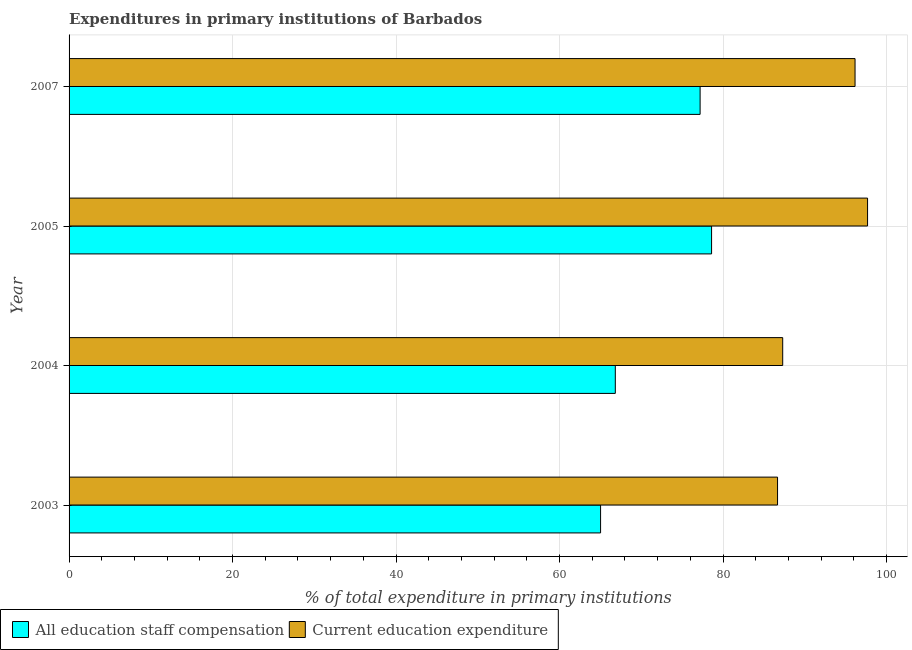How many groups of bars are there?
Keep it short and to the point. 4. Are the number of bars on each tick of the Y-axis equal?
Your answer should be very brief. Yes. How many bars are there on the 1st tick from the bottom?
Give a very brief answer. 2. What is the label of the 4th group of bars from the top?
Offer a very short reply. 2003. What is the expenditure in staff compensation in 2004?
Provide a short and direct response. 66.82. Across all years, what is the maximum expenditure in staff compensation?
Your answer should be very brief. 78.59. Across all years, what is the minimum expenditure in education?
Ensure brevity in your answer.  86.66. In which year was the expenditure in staff compensation maximum?
Make the answer very short. 2005. In which year was the expenditure in education minimum?
Your answer should be compact. 2003. What is the total expenditure in education in the graph?
Make the answer very short. 367.78. What is the difference between the expenditure in staff compensation in 2005 and that in 2007?
Provide a short and direct response. 1.4. What is the difference between the expenditure in education in 2005 and the expenditure in staff compensation in 2007?
Your response must be concise. 20.48. What is the average expenditure in staff compensation per year?
Give a very brief answer. 71.91. In the year 2004, what is the difference between the expenditure in staff compensation and expenditure in education?
Your answer should be very brief. -20.48. In how many years, is the expenditure in education greater than 72 %?
Ensure brevity in your answer.  4. What is the ratio of the expenditure in staff compensation in 2005 to that in 2007?
Make the answer very short. 1.02. Is the expenditure in education in 2003 less than that in 2004?
Provide a succinct answer. Yes. What is the difference between the highest and the second highest expenditure in staff compensation?
Provide a short and direct response. 1.4. What is the difference between the highest and the lowest expenditure in education?
Keep it short and to the point. 11.01. What does the 2nd bar from the top in 2004 represents?
Your answer should be compact. All education staff compensation. What does the 2nd bar from the bottom in 2007 represents?
Offer a very short reply. Current education expenditure. Are all the bars in the graph horizontal?
Your response must be concise. Yes. What is the difference between two consecutive major ticks on the X-axis?
Provide a short and direct response. 20. Does the graph contain any zero values?
Keep it short and to the point. No. Does the graph contain grids?
Give a very brief answer. Yes. Where does the legend appear in the graph?
Make the answer very short. Bottom left. How many legend labels are there?
Give a very brief answer. 2. How are the legend labels stacked?
Your response must be concise. Horizontal. What is the title of the graph?
Your response must be concise. Expenditures in primary institutions of Barbados. Does "Primary education" appear as one of the legend labels in the graph?
Ensure brevity in your answer.  No. What is the label or title of the X-axis?
Offer a very short reply. % of total expenditure in primary institutions. What is the label or title of the Y-axis?
Provide a short and direct response. Year. What is the % of total expenditure in primary institutions in All education staff compensation in 2003?
Give a very brief answer. 65.02. What is the % of total expenditure in primary institutions of Current education expenditure in 2003?
Offer a terse response. 86.66. What is the % of total expenditure in primary institutions in All education staff compensation in 2004?
Offer a very short reply. 66.82. What is the % of total expenditure in primary institutions in Current education expenditure in 2004?
Your response must be concise. 87.29. What is the % of total expenditure in primary institutions of All education staff compensation in 2005?
Offer a very short reply. 78.59. What is the % of total expenditure in primary institutions of Current education expenditure in 2005?
Your answer should be very brief. 97.68. What is the % of total expenditure in primary institutions of All education staff compensation in 2007?
Offer a terse response. 77.19. What is the % of total expenditure in primary institutions of Current education expenditure in 2007?
Offer a very short reply. 96.14. Across all years, what is the maximum % of total expenditure in primary institutions in All education staff compensation?
Keep it short and to the point. 78.59. Across all years, what is the maximum % of total expenditure in primary institutions of Current education expenditure?
Your response must be concise. 97.68. Across all years, what is the minimum % of total expenditure in primary institutions of All education staff compensation?
Your answer should be compact. 65.02. Across all years, what is the minimum % of total expenditure in primary institutions in Current education expenditure?
Offer a terse response. 86.66. What is the total % of total expenditure in primary institutions of All education staff compensation in the graph?
Ensure brevity in your answer.  287.62. What is the total % of total expenditure in primary institutions in Current education expenditure in the graph?
Ensure brevity in your answer.  367.78. What is the difference between the % of total expenditure in primary institutions of All education staff compensation in 2003 and that in 2004?
Keep it short and to the point. -1.8. What is the difference between the % of total expenditure in primary institutions in Current education expenditure in 2003 and that in 2004?
Offer a terse response. -0.63. What is the difference between the % of total expenditure in primary institutions in All education staff compensation in 2003 and that in 2005?
Your answer should be very brief. -13.58. What is the difference between the % of total expenditure in primary institutions of Current education expenditure in 2003 and that in 2005?
Keep it short and to the point. -11.01. What is the difference between the % of total expenditure in primary institutions in All education staff compensation in 2003 and that in 2007?
Give a very brief answer. -12.17. What is the difference between the % of total expenditure in primary institutions in Current education expenditure in 2003 and that in 2007?
Make the answer very short. -9.48. What is the difference between the % of total expenditure in primary institutions in All education staff compensation in 2004 and that in 2005?
Your answer should be compact. -11.77. What is the difference between the % of total expenditure in primary institutions of Current education expenditure in 2004 and that in 2005?
Your answer should be compact. -10.38. What is the difference between the % of total expenditure in primary institutions in All education staff compensation in 2004 and that in 2007?
Provide a succinct answer. -10.37. What is the difference between the % of total expenditure in primary institutions of Current education expenditure in 2004 and that in 2007?
Ensure brevity in your answer.  -8.85. What is the difference between the % of total expenditure in primary institutions in All education staff compensation in 2005 and that in 2007?
Provide a succinct answer. 1.4. What is the difference between the % of total expenditure in primary institutions in Current education expenditure in 2005 and that in 2007?
Ensure brevity in your answer.  1.53. What is the difference between the % of total expenditure in primary institutions in All education staff compensation in 2003 and the % of total expenditure in primary institutions in Current education expenditure in 2004?
Offer a terse response. -22.28. What is the difference between the % of total expenditure in primary institutions in All education staff compensation in 2003 and the % of total expenditure in primary institutions in Current education expenditure in 2005?
Offer a very short reply. -32.66. What is the difference between the % of total expenditure in primary institutions in All education staff compensation in 2003 and the % of total expenditure in primary institutions in Current education expenditure in 2007?
Give a very brief answer. -31.13. What is the difference between the % of total expenditure in primary institutions in All education staff compensation in 2004 and the % of total expenditure in primary institutions in Current education expenditure in 2005?
Give a very brief answer. -30.86. What is the difference between the % of total expenditure in primary institutions in All education staff compensation in 2004 and the % of total expenditure in primary institutions in Current education expenditure in 2007?
Offer a terse response. -29.32. What is the difference between the % of total expenditure in primary institutions of All education staff compensation in 2005 and the % of total expenditure in primary institutions of Current education expenditure in 2007?
Give a very brief answer. -17.55. What is the average % of total expenditure in primary institutions of All education staff compensation per year?
Give a very brief answer. 71.9. What is the average % of total expenditure in primary institutions in Current education expenditure per year?
Ensure brevity in your answer.  91.94. In the year 2003, what is the difference between the % of total expenditure in primary institutions in All education staff compensation and % of total expenditure in primary institutions in Current education expenditure?
Make the answer very short. -21.65. In the year 2004, what is the difference between the % of total expenditure in primary institutions in All education staff compensation and % of total expenditure in primary institutions in Current education expenditure?
Offer a very short reply. -20.47. In the year 2005, what is the difference between the % of total expenditure in primary institutions in All education staff compensation and % of total expenditure in primary institutions in Current education expenditure?
Offer a very short reply. -19.08. In the year 2007, what is the difference between the % of total expenditure in primary institutions in All education staff compensation and % of total expenditure in primary institutions in Current education expenditure?
Provide a short and direct response. -18.95. What is the ratio of the % of total expenditure in primary institutions in All education staff compensation in 2003 to that in 2004?
Your response must be concise. 0.97. What is the ratio of the % of total expenditure in primary institutions in All education staff compensation in 2003 to that in 2005?
Your answer should be very brief. 0.83. What is the ratio of the % of total expenditure in primary institutions of Current education expenditure in 2003 to that in 2005?
Provide a succinct answer. 0.89. What is the ratio of the % of total expenditure in primary institutions of All education staff compensation in 2003 to that in 2007?
Make the answer very short. 0.84. What is the ratio of the % of total expenditure in primary institutions of Current education expenditure in 2003 to that in 2007?
Ensure brevity in your answer.  0.9. What is the ratio of the % of total expenditure in primary institutions in All education staff compensation in 2004 to that in 2005?
Provide a short and direct response. 0.85. What is the ratio of the % of total expenditure in primary institutions of Current education expenditure in 2004 to that in 2005?
Your response must be concise. 0.89. What is the ratio of the % of total expenditure in primary institutions of All education staff compensation in 2004 to that in 2007?
Your response must be concise. 0.87. What is the ratio of the % of total expenditure in primary institutions of Current education expenditure in 2004 to that in 2007?
Make the answer very short. 0.91. What is the ratio of the % of total expenditure in primary institutions of All education staff compensation in 2005 to that in 2007?
Give a very brief answer. 1.02. What is the ratio of the % of total expenditure in primary institutions of Current education expenditure in 2005 to that in 2007?
Ensure brevity in your answer.  1.02. What is the difference between the highest and the second highest % of total expenditure in primary institutions in All education staff compensation?
Offer a very short reply. 1.4. What is the difference between the highest and the second highest % of total expenditure in primary institutions of Current education expenditure?
Provide a short and direct response. 1.53. What is the difference between the highest and the lowest % of total expenditure in primary institutions of All education staff compensation?
Your answer should be compact. 13.58. What is the difference between the highest and the lowest % of total expenditure in primary institutions in Current education expenditure?
Provide a short and direct response. 11.01. 